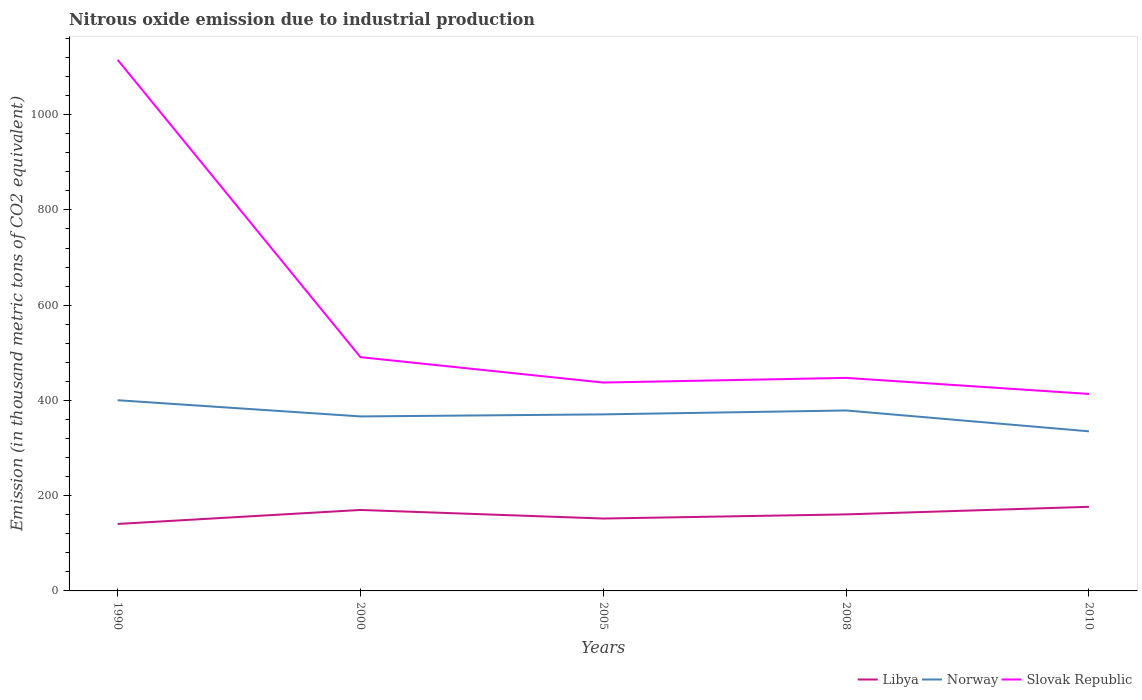Is the number of lines equal to the number of legend labels?
Offer a very short reply. Yes. Across all years, what is the maximum amount of nitrous oxide emitted in Norway?
Give a very brief answer. 335.1. In which year was the amount of nitrous oxide emitted in Slovak Republic maximum?
Ensure brevity in your answer.  2010. What is the total amount of nitrous oxide emitted in Libya in the graph?
Your answer should be very brief. -8.7. Is the amount of nitrous oxide emitted in Norway strictly greater than the amount of nitrous oxide emitted in Slovak Republic over the years?
Offer a very short reply. Yes. How many lines are there?
Your answer should be compact. 3. What is the difference between two consecutive major ticks on the Y-axis?
Keep it short and to the point. 200. Does the graph contain any zero values?
Give a very brief answer. No. Does the graph contain grids?
Your answer should be compact. No. Where does the legend appear in the graph?
Your answer should be very brief. Bottom right. How many legend labels are there?
Make the answer very short. 3. How are the legend labels stacked?
Your response must be concise. Horizontal. What is the title of the graph?
Keep it short and to the point. Nitrous oxide emission due to industrial production. What is the label or title of the Y-axis?
Offer a terse response. Emission (in thousand metric tons of CO2 equivalent). What is the Emission (in thousand metric tons of CO2 equivalent) in Libya in 1990?
Give a very brief answer. 140.6. What is the Emission (in thousand metric tons of CO2 equivalent) in Norway in 1990?
Your answer should be very brief. 400.4. What is the Emission (in thousand metric tons of CO2 equivalent) of Slovak Republic in 1990?
Keep it short and to the point. 1115.2. What is the Emission (in thousand metric tons of CO2 equivalent) of Libya in 2000?
Offer a very short reply. 170. What is the Emission (in thousand metric tons of CO2 equivalent) in Norway in 2000?
Ensure brevity in your answer.  366.4. What is the Emission (in thousand metric tons of CO2 equivalent) in Slovak Republic in 2000?
Ensure brevity in your answer.  490.8. What is the Emission (in thousand metric tons of CO2 equivalent) of Libya in 2005?
Provide a short and direct response. 152. What is the Emission (in thousand metric tons of CO2 equivalent) of Norway in 2005?
Give a very brief answer. 370.7. What is the Emission (in thousand metric tons of CO2 equivalent) in Slovak Republic in 2005?
Offer a very short reply. 437.5. What is the Emission (in thousand metric tons of CO2 equivalent) of Libya in 2008?
Your answer should be very brief. 160.7. What is the Emission (in thousand metric tons of CO2 equivalent) of Norway in 2008?
Your answer should be compact. 378.9. What is the Emission (in thousand metric tons of CO2 equivalent) of Slovak Republic in 2008?
Your response must be concise. 447.3. What is the Emission (in thousand metric tons of CO2 equivalent) of Libya in 2010?
Offer a very short reply. 176.6. What is the Emission (in thousand metric tons of CO2 equivalent) in Norway in 2010?
Provide a short and direct response. 335.1. What is the Emission (in thousand metric tons of CO2 equivalent) in Slovak Republic in 2010?
Keep it short and to the point. 413.6. Across all years, what is the maximum Emission (in thousand metric tons of CO2 equivalent) in Libya?
Provide a succinct answer. 176.6. Across all years, what is the maximum Emission (in thousand metric tons of CO2 equivalent) of Norway?
Provide a succinct answer. 400.4. Across all years, what is the maximum Emission (in thousand metric tons of CO2 equivalent) in Slovak Republic?
Give a very brief answer. 1115.2. Across all years, what is the minimum Emission (in thousand metric tons of CO2 equivalent) in Libya?
Ensure brevity in your answer.  140.6. Across all years, what is the minimum Emission (in thousand metric tons of CO2 equivalent) of Norway?
Give a very brief answer. 335.1. Across all years, what is the minimum Emission (in thousand metric tons of CO2 equivalent) in Slovak Republic?
Make the answer very short. 413.6. What is the total Emission (in thousand metric tons of CO2 equivalent) in Libya in the graph?
Your answer should be compact. 799.9. What is the total Emission (in thousand metric tons of CO2 equivalent) in Norway in the graph?
Ensure brevity in your answer.  1851.5. What is the total Emission (in thousand metric tons of CO2 equivalent) of Slovak Republic in the graph?
Your answer should be compact. 2904.4. What is the difference between the Emission (in thousand metric tons of CO2 equivalent) in Libya in 1990 and that in 2000?
Your answer should be compact. -29.4. What is the difference between the Emission (in thousand metric tons of CO2 equivalent) in Norway in 1990 and that in 2000?
Make the answer very short. 34. What is the difference between the Emission (in thousand metric tons of CO2 equivalent) of Slovak Republic in 1990 and that in 2000?
Give a very brief answer. 624.4. What is the difference between the Emission (in thousand metric tons of CO2 equivalent) of Libya in 1990 and that in 2005?
Offer a terse response. -11.4. What is the difference between the Emission (in thousand metric tons of CO2 equivalent) of Norway in 1990 and that in 2005?
Offer a terse response. 29.7. What is the difference between the Emission (in thousand metric tons of CO2 equivalent) of Slovak Republic in 1990 and that in 2005?
Offer a terse response. 677.7. What is the difference between the Emission (in thousand metric tons of CO2 equivalent) of Libya in 1990 and that in 2008?
Provide a succinct answer. -20.1. What is the difference between the Emission (in thousand metric tons of CO2 equivalent) of Norway in 1990 and that in 2008?
Your answer should be very brief. 21.5. What is the difference between the Emission (in thousand metric tons of CO2 equivalent) of Slovak Republic in 1990 and that in 2008?
Your answer should be very brief. 667.9. What is the difference between the Emission (in thousand metric tons of CO2 equivalent) in Libya in 1990 and that in 2010?
Ensure brevity in your answer.  -36. What is the difference between the Emission (in thousand metric tons of CO2 equivalent) in Norway in 1990 and that in 2010?
Provide a succinct answer. 65.3. What is the difference between the Emission (in thousand metric tons of CO2 equivalent) of Slovak Republic in 1990 and that in 2010?
Provide a short and direct response. 701.6. What is the difference between the Emission (in thousand metric tons of CO2 equivalent) in Norway in 2000 and that in 2005?
Offer a terse response. -4.3. What is the difference between the Emission (in thousand metric tons of CO2 equivalent) in Slovak Republic in 2000 and that in 2005?
Provide a short and direct response. 53.3. What is the difference between the Emission (in thousand metric tons of CO2 equivalent) of Libya in 2000 and that in 2008?
Keep it short and to the point. 9.3. What is the difference between the Emission (in thousand metric tons of CO2 equivalent) in Slovak Republic in 2000 and that in 2008?
Provide a succinct answer. 43.5. What is the difference between the Emission (in thousand metric tons of CO2 equivalent) in Norway in 2000 and that in 2010?
Provide a succinct answer. 31.3. What is the difference between the Emission (in thousand metric tons of CO2 equivalent) of Slovak Republic in 2000 and that in 2010?
Provide a short and direct response. 77.2. What is the difference between the Emission (in thousand metric tons of CO2 equivalent) in Libya in 2005 and that in 2008?
Provide a short and direct response. -8.7. What is the difference between the Emission (in thousand metric tons of CO2 equivalent) in Norway in 2005 and that in 2008?
Give a very brief answer. -8.2. What is the difference between the Emission (in thousand metric tons of CO2 equivalent) in Libya in 2005 and that in 2010?
Give a very brief answer. -24.6. What is the difference between the Emission (in thousand metric tons of CO2 equivalent) in Norway in 2005 and that in 2010?
Make the answer very short. 35.6. What is the difference between the Emission (in thousand metric tons of CO2 equivalent) of Slovak Republic in 2005 and that in 2010?
Offer a very short reply. 23.9. What is the difference between the Emission (in thousand metric tons of CO2 equivalent) of Libya in 2008 and that in 2010?
Provide a short and direct response. -15.9. What is the difference between the Emission (in thousand metric tons of CO2 equivalent) in Norway in 2008 and that in 2010?
Give a very brief answer. 43.8. What is the difference between the Emission (in thousand metric tons of CO2 equivalent) of Slovak Republic in 2008 and that in 2010?
Keep it short and to the point. 33.7. What is the difference between the Emission (in thousand metric tons of CO2 equivalent) of Libya in 1990 and the Emission (in thousand metric tons of CO2 equivalent) of Norway in 2000?
Keep it short and to the point. -225.8. What is the difference between the Emission (in thousand metric tons of CO2 equivalent) of Libya in 1990 and the Emission (in thousand metric tons of CO2 equivalent) of Slovak Republic in 2000?
Make the answer very short. -350.2. What is the difference between the Emission (in thousand metric tons of CO2 equivalent) in Norway in 1990 and the Emission (in thousand metric tons of CO2 equivalent) in Slovak Republic in 2000?
Keep it short and to the point. -90.4. What is the difference between the Emission (in thousand metric tons of CO2 equivalent) of Libya in 1990 and the Emission (in thousand metric tons of CO2 equivalent) of Norway in 2005?
Provide a succinct answer. -230.1. What is the difference between the Emission (in thousand metric tons of CO2 equivalent) in Libya in 1990 and the Emission (in thousand metric tons of CO2 equivalent) in Slovak Republic in 2005?
Your answer should be very brief. -296.9. What is the difference between the Emission (in thousand metric tons of CO2 equivalent) in Norway in 1990 and the Emission (in thousand metric tons of CO2 equivalent) in Slovak Republic in 2005?
Make the answer very short. -37.1. What is the difference between the Emission (in thousand metric tons of CO2 equivalent) of Libya in 1990 and the Emission (in thousand metric tons of CO2 equivalent) of Norway in 2008?
Provide a succinct answer. -238.3. What is the difference between the Emission (in thousand metric tons of CO2 equivalent) in Libya in 1990 and the Emission (in thousand metric tons of CO2 equivalent) in Slovak Republic in 2008?
Your response must be concise. -306.7. What is the difference between the Emission (in thousand metric tons of CO2 equivalent) in Norway in 1990 and the Emission (in thousand metric tons of CO2 equivalent) in Slovak Republic in 2008?
Keep it short and to the point. -46.9. What is the difference between the Emission (in thousand metric tons of CO2 equivalent) in Libya in 1990 and the Emission (in thousand metric tons of CO2 equivalent) in Norway in 2010?
Provide a succinct answer. -194.5. What is the difference between the Emission (in thousand metric tons of CO2 equivalent) in Libya in 1990 and the Emission (in thousand metric tons of CO2 equivalent) in Slovak Republic in 2010?
Provide a short and direct response. -273. What is the difference between the Emission (in thousand metric tons of CO2 equivalent) in Norway in 1990 and the Emission (in thousand metric tons of CO2 equivalent) in Slovak Republic in 2010?
Your response must be concise. -13.2. What is the difference between the Emission (in thousand metric tons of CO2 equivalent) of Libya in 2000 and the Emission (in thousand metric tons of CO2 equivalent) of Norway in 2005?
Make the answer very short. -200.7. What is the difference between the Emission (in thousand metric tons of CO2 equivalent) of Libya in 2000 and the Emission (in thousand metric tons of CO2 equivalent) of Slovak Republic in 2005?
Keep it short and to the point. -267.5. What is the difference between the Emission (in thousand metric tons of CO2 equivalent) in Norway in 2000 and the Emission (in thousand metric tons of CO2 equivalent) in Slovak Republic in 2005?
Offer a very short reply. -71.1. What is the difference between the Emission (in thousand metric tons of CO2 equivalent) of Libya in 2000 and the Emission (in thousand metric tons of CO2 equivalent) of Norway in 2008?
Offer a terse response. -208.9. What is the difference between the Emission (in thousand metric tons of CO2 equivalent) of Libya in 2000 and the Emission (in thousand metric tons of CO2 equivalent) of Slovak Republic in 2008?
Provide a succinct answer. -277.3. What is the difference between the Emission (in thousand metric tons of CO2 equivalent) in Norway in 2000 and the Emission (in thousand metric tons of CO2 equivalent) in Slovak Republic in 2008?
Your answer should be compact. -80.9. What is the difference between the Emission (in thousand metric tons of CO2 equivalent) of Libya in 2000 and the Emission (in thousand metric tons of CO2 equivalent) of Norway in 2010?
Your response must be concise. -165.1. What is the difference between the Emission (in thousand metric tons of CO2 equivalent) of Libya in 2000 and the Emission (in thousand metric tons of CO2 equivalent) of Slovak Republic in 2010?
Your answer should be very brief. -243.6. What is the difference between the Emission (in thousand metric tons of CO2 equivalent) in Norway in 2000 and the Emission (in thousand metric tons of CO2 equivalent) in Slovak Republic in 2010?
Offer a terse response. -47.2. What is the difference between the Emission (in thousand metric tons of CO2 equivalent) of Libya in 2005 and the Emission (in thousand metric tons of CO2 equivalent) of Norway in 2008?
Provide a short and direct response. -226.9. What is the difference between the Emission (in thousand metric tons of CO2 equivalent) of Libya in 2005 and the Emission (in thousand metric tons of CO2 equivalent) of Slovak Republic in 2008?
Give a very brief answer. -295.3. What is the difference between the Emission (in thousand metric tons of CO2 equivalent) in Norway in 2005 and the Emission (in thousand metric tons of CO2 equivalent) in Slovak Republic in 2008?
Ensure brevity in your answer.  -76.6. What is the difference between the Emission (in thousand metric tons of CO2 equivalent) of Libya in 2005 and the Emission (in thousand metric tons of CO2 equivalent) of Norway in 2010?
Make the answer very short. -183.1. What is the difference between the Emission (in thousand metric tons of CO2 equivalent) in Libya in 2005 and the Emission (in thousand metric tons of CO2 equivalent) in Slovak Republic in 2010?
Make the answer very short. -261.6. What is the difference between the Emission (in thousand metric tons of CO2 equivalent) of Norway in 2005 and the Emission (in thousand metric tons of CO2 equivalent) of Slovak Republic in 2010?
Provide a short and direct response. -42.9. What is the difference between the Emission (in thousand metric tons of CO2 equivalent) in Libya in 2008 and the Emission (in thousand metric tons of CO2 equivalent) in Norway in 2010?
Give a very brief answer. -174.4. What is the difference between the Emission (in thousand metric tons of CO2 equivalent) in Libya in 2008 and the Emission (in thousand metric tons of CO2 equivalent) in Slovak Republic in 2010?
Your answer should be compact. -252.9. What is the difference between the Emission (in thousand metric tons of CO2 equivalent) of Norway in 2008 and the Emission (in thousand metric tons of CO2 equivalent) of Slovak Republic in 2010?
Provide a short and direct response. -34.7. What is the average Emission (in thousand metric tons of CO2 equivalent) in Libya per year?
Ensure brevity in your answer.  159.98. What is the average Emission (in thousand metric tons of CO2 equivalent) in Norway per year?
Offer a terse response. 370.3. What is the average Emission (in thousand metric tons of CO2 equivalent) of Slovak Republic per year?
Ensure brevity in your answer.  580.88. In the year 1990, what is the difference between the Emission (in thousand metric tons of CO2 equivalent) of Libya and Emission (in thousand metric tons of CO2 equivalent) of Norway?
Provide a succinct answer. -259.8. In the year 1990, what is the difference between the Emission (in thousand metric tons of CO2 equivalent) of Libya and Emission (in thousand metric tons of CO2 equivalent) of Slovak Republic?
Give a very brief answer. -974.6. In the year 1990, what is the difference between the Emission (in thousand metric tons of CO2 equivalent) in Norway and Emission (in thousand metric tons of CO2 equivalent) in Slovak Republic?
Provide a succinct answer. -714.8. In the year 2000, what is the difference between the Emission (in thousand metric tons of CO2 equivalent) of Libya and Emission (in thousand metric tons of CO2 equivalent) of Norway?
Your answer should be compact. -196.4. In the year 2000, what is the difference between the Emission (in thousand metric tons of CO2 equivalent) in Libya and Emission (in thousand metric tons of CO2 equivalent) in Slovak Republic?
Offer a terse response. -320.8. In the year 2000, what is the difference between the Emission (in thousand metric tons of CO2 equivalent) in Norway and Emission (in thousand metric tons of CO2 equivalent) in Slovak Republic?
Keep it short and to the point. -124.4. In the year 2005, what is the difference between the Emission (in thousand metric tons of CO2 equivalent) in Libya and Emission (in thousand metric tons of CO2 equivalent) in Norway?
Provide a short and direct response. -218.7. In the year 2005, what is the difference between the Emission (in thousand metric tons of CO2 equivalent) of Libya and Emission (in thousand metric tons of CO2 equivalent) of Slovak Republic?
Your response must be concise. -285.5. In the year 2005, what is the difference between the Emission (in thousand metric tons of CO2 equivalent) of Norway and Emission (in thousand metric tons of CO2 equivalent) of Slovak Republic?
Offer a terse response. -66.8. In the year 2008, what is the difference between the Emission (in thousand metric tons of CO2 equivalent) in Libya and Emission (in thousand metric tons of CO2 equivalent) in Norway?
Give a very brief answer. -218.2. In the year 2008, what is the difference between the Emission (in thousand metric tons of CO2 equivalent) in Libya and Emission (in thousand metric tons of CO2 equivalent) in Slovak Republic?
Your answer should be very brief. -286.6. In the year 2008, what is the difference between the Emission (in thousand metric tons of CO2 equivalent) of Norway and Emission (in thousand metric tons of CO2 equivalent) of Slovak Republic?
Keep it short and to the point. -68.4. In the year 2010, what is the difference between the Emission (in thousand metric tons of CO2 equivalent) of Libya and Emission (in thousand metric tons of CO2 equivalent) of Norway?
Your answer should be very brief. -158.5. In the year 2010, what is the difference between the Emission (in thousand metric tons of CO2 equivalent) in Libya and Emission (in thousand metric tons of CO2 equivalent) in Slovak Republic?
Offer a terse response. -237. In the year 2010, what is the difference between the Emission (in thousand metric tons of CO2 equivalent) of Norway and Emission (in thousand metric tons of CO2 equivalent) of Slovak Republic?
Make the answer very short. -78.5. What is the ratio of the Emission (in thousand metric tons of CO2 equivalent) in Libya in 1990 to that in 2000?
Provide a short and direct response. 0.83. What is the ratio of the Emission (in thousand metric tons of CO2 equivalent) of Norway in 1990 to that in 2000?
Give a very brief answer. 1.09. What is the ratio of the Emission (in thousand metric tons of CO2 equivalent) of Slovak Republic in 1990 to that in 2000?
Provide a short and direct response. 2.27. What is the ratio of the Emission (in thousand metric tons of CO2 equivalent) of Libya in 1990 to that in 2005?
Offer a very short reply. 0.93. What is the ratio of the Emission (in thousand metric tons of CO2 equivalent) in Norway in 1990 to that in 2005?
Make the answer very short. 1.08. What is the ratio of the Emission (in thousand metric tons of CO2 equivalent) in Slovak Republic in 1990 to that in 2005?
Your answer should be compact. 2.55. What is the ratio of the Emission (in thousand metric tons of CO2 equivalent) of Libya in 1990 to that in 2008?
Keep it short and to the point. 0.87. What is the ratio of the Emission (in thousand metric tons of CO2 equivalent) in Norway in 1990 to that in 2008?
Keep it short and to the point. 1.06. What is the ratio of the Emission (in thousand metric tons of CO2 equivalent) in Slovak Republic in 1990 to that in 2008?
Offer a terse response. 2.49. What is the ratio of the Emission (in thousand metric tons of CO2 equivalent) of Libya in 1990 to that in 2010?
Make the answer very short. 0.8. What is the ratio of the Emission (in thousand metric tons of CO2 equivalent) of Norway in 1990 to that in 2010?
Your response must be concise. 1.19. What is the ratio of the Emission (in thousand metric tons of CO2 equivalent) of Slovak Republic in 1990 to that in 2010?
Your answer should be very brief. 2.7. What is the ratio of the Emission (in thousand metric tons of CO2 equivalent) of Libya in 2000 to that in 2005?
Your answer should be very brief. 1.12. What is the ratio of the Emission (in thousand metric tons of CO2 equivalent) of Norway in 2000 to that in 2005?
Make the answer very short. 0.99. What is the ratio of the Emission (in thousand metric tons of CO2 equivalent) in Slovak Republic in 2000 to that in 2005?
Offer a very short reply. 1.12. What is the ratio of the Emission (in thousand metric tons of CO2 equivalent) of Libya in 2000 to that in 2008?
Provide a succinct answer. 1.06. What is the ratio of the Emission (in thousand metric tons of CO2 equivalent) of Slovak Republic in 2000 to that in 2008?
Ensure brevity in your answer.  1.1. What is the ratio of the Emission (in thousand metric tons of CO2 equivalent) in Libya in 2000 to that in 2010?
Make the answer very short. 0.96. What is the ratio of the Emission (in thousand metric tons of CO2 equivalent) of Norway in 2000 to that in 2010?
Make the answer very short. 1.09. What is the ratio of the Emission (in thousand metric tons of CO2 equivalent) in Slovak Republic in 2000 to that in 2010?
Provide a succinct answer. 1.19. What is the ratio of the Emission (in thousand metric tons of CO2 equivalent) in Libya in 2005 to that in 2008?
Give a very brief answer. 0.95. What is the ratio of the Emission (in thousand metric tons of CO2 equivalent) of Norway in 2005 to that in 2008?
Your response must be concise. 0.98. What is the ratio of the Emission (in thousand metric tons of CO2 equivalent) in Slovak Republic in 2005 to that in 2008?
Provide a succinct answer. 0.98. What is the ratio of the Emission (in thousand metric tons of CO2 equivalent) of Libya in 2005 to that in 2010?
Offer a terse response. 0.86. What is the ratio of the Emission (in thousand metric tons of CO2 equivalent) of Norway in 2005 to that in 2010?
Offer a very short reply. 1.11. What is the ratio of the Emission (in thousand metric tons of CO2 equivalent) of Slovak Republic in 2005 to that in 2010?
Ensure brevity in your answer.  1.06. What is the ratio of the Emission (in thousand metric tons of CO2 equivalent) in Libya in 2008 to that in 2010?
Give a very brief answer. 0.91. What is the ratio of the Emission (in thousand metric tons of CO2 equivalent) in Norway in 2008 to that in 2010?
Your answer should be very brief. 1.13. What is the ratio of the Emission (in thousand metric tons of CO2 equivalent) of Slovak Republic in 2008 to that in 2010?
Make the answer very short. 1.08. What is the difference between the highest and the second highest Emission (in thousand metric tons of CO2 equivalent) of Norway?
Provide a short and direct response. 21.5. What is the difference between the highest and the second highest Emission (in thousand metric tons of CO2 equivalent) in Slovak Republic?
Offer a very short reply. 624.4. What is the difference between the highest and the lowest Emission (in thousand metric tons of CO2 equivalent) in Norway?
Your answer should be very brief. 65.3. What is the difference between the highest and the lowest Emission (in thousand metric tons of CO2 equivalent) in Slovak Republic?
Ensure brevity in your answer.  701.6. 